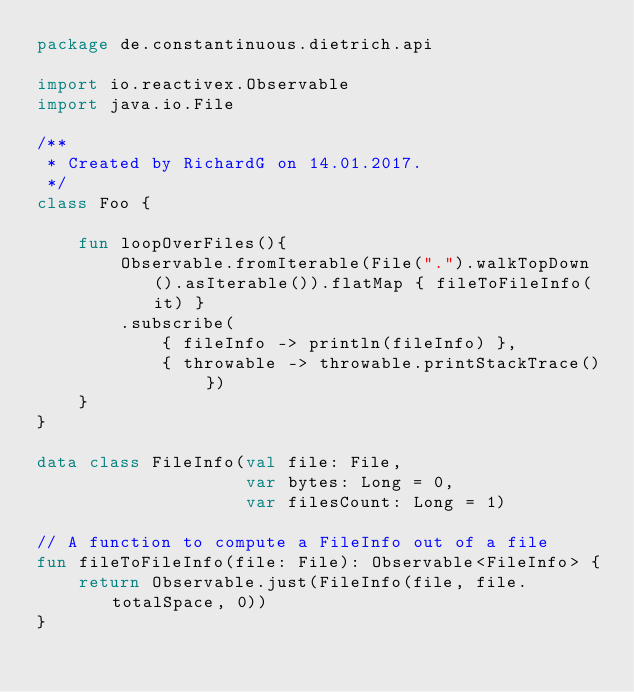<code> <loc_0><loc_0><loc_500><loc_500><_Kotlin_>package de.constantinuous.dietrich.api

import io.reactivex.Observable
import java.io.File

/**
 * Created by RichardG on 14.01.2017.
 */
class Foo {

    fun loopOverFiles(){
        Observable.fromIterable(File(".").walkTopDown().asIterable()).flatMap { fileToFileInfo(it) }
        .subscribe(
            { fileInfo -> println(fileInfo) },
            { throwable -> throwable.printStackTrace() })
    }
}

data class FileInfo(val file: File,
                    var bytes: Long = 0,
                    var filesCount: Long = 1)

// A function to compute a FileInfo out of a file
fun fileToFileInfo(file: File): Observable<FileInfo> {
    return Observable.just(FileInfo(file, file.totalSpace, 0))
}</code> 